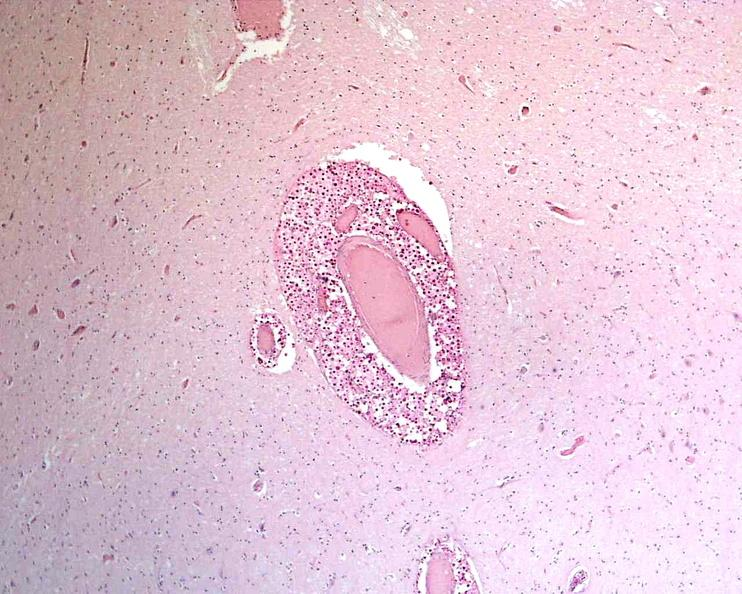s supernumerary digit present?
Answer the question using a single word or phrase. No 